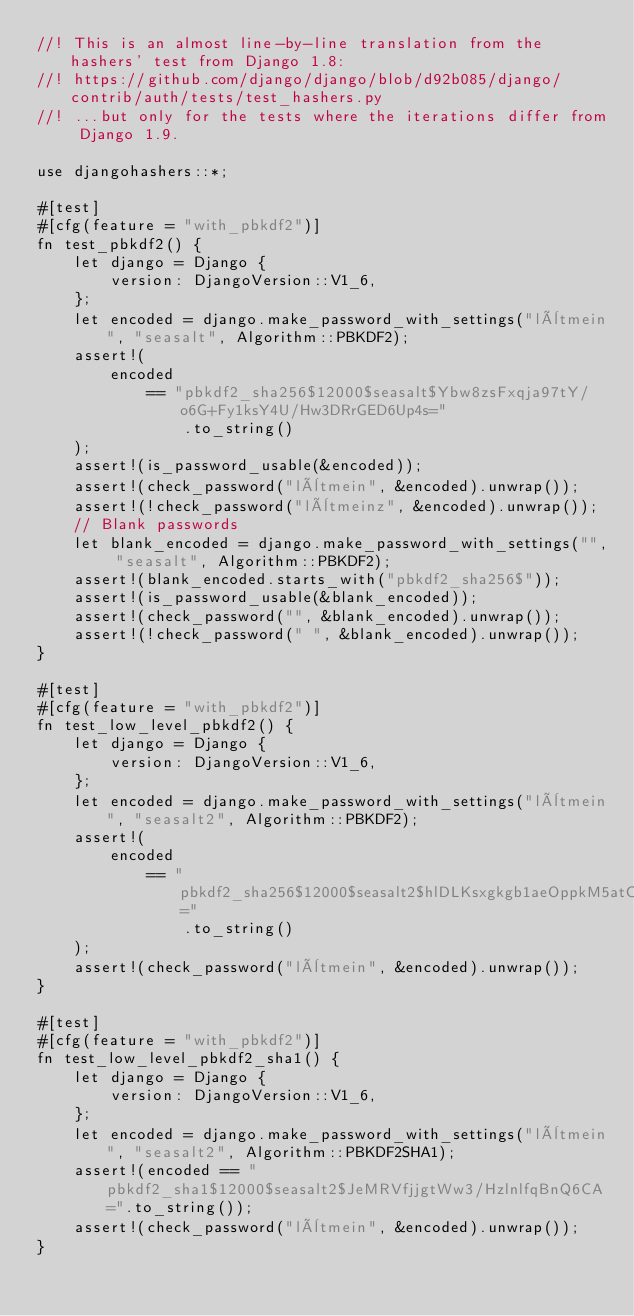<code> <loc_0><loc_0><loc_500><loc_500><_Rust_>//! This is an almost line-by-line translation from the hashers' test from Django 1.8:
//! https://github.com/django/django/blob/d92b085/django/contrib/auth/tests/test_hashers.py
//! ...but only for the tests where the iterations differ from Django 1.9.

use djangohashers::*;

#[test]
#[cfg(feature = "with_pbkdf2")]
fn test_pbkdf2() {
    let django = Django {
        version: DjangoVersion::V1_6,
    };
    let encoded = django.make_password_with_settings("lètmein", "seasalt", Algorithm::PBKDF2);
    assert!(
        encoded
            == "pbkdf2_sha256$12000$seasalt$Ybw8zsFxqja97tY/o6G+Fy1ksY4U/Hw3DRrGED6Up4s="
                .to_string()
    );
    assert!(is_password_usable(&encoded));
    assert!(check_password("lètmein", &encoded).unwrap());
    assert!(!check_password("lètmeinz", &encoded).unwrap());
    // Blank passwords
    let blank_encoded = django.make_password_with_settings("", "seasalt", Algorithm::PBKDF2);
    assert!(blank_encoded.starts_with("pbkdf2_sha256$"));
    assert!(is_password_usable(&blank_encoded));
    assert!(check_password("", &blank_encoded).unwrap());
    assert!(!check_password(" ", &blank_encoded).unwrap());
}

#[test]
#[cfg(feature = "with_pbkdf2")]
fn test_low_level_pbkdf2() {
    let django = Django {
        version: DjangoVersion::V1_6,
    };
    let encoded = django.make_password_with_settings("lètmein", "seasalt2", Algorithm::PBKDF2);
    assert!(
        encoded
            == "pbkdf2_sha256$12000$seasalt2$hlDLKsxgkgb1aeOppkM5atCYw5rPzAjCNQZ4NYyUROw="
                .to_string()
    );
    assert!(check_password("lètmein", &encoded).unwrap());
}

#[test]
#[cfg(feature = "with_pbkdf2")]
fn test_low_level_pbkdf2_sha1() {
    let django = Django {
        version: DjangoVersion::V1_6,
    };
    let encoded = django.make_password_with_settings("lètmein", "seasalt2", Algorithm::PBKDF2SHA1);
    assert!(encoded == "pbkdf2_sha1$12000$seasalt2$JeMRVfjjgtWw3/HzlnlfqBnQ6CA=".to_string());
    assert!(check_password("lètmein", &encoded).unwrap());
}
</code> 